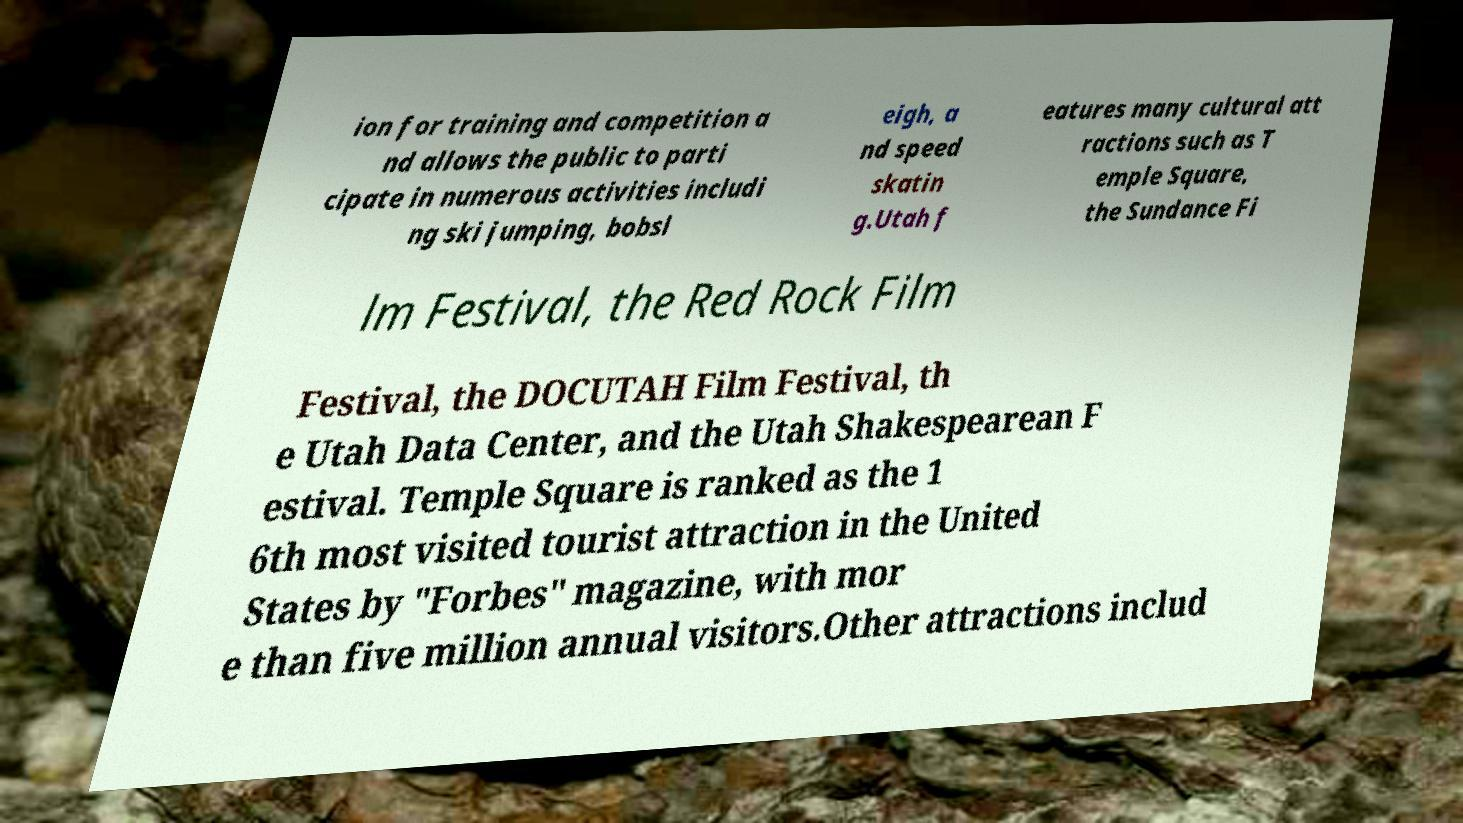Can you accurately transcribe the text from the provided image for me? ion for training and competition a nd allows the public to parti cipate in numerous activities includi ng ski jumping, bobsl eigh, a nd speed skatin g.Utah f eatures many cultural att ractions such as T emple Square, the Sundance Fi lm Festival, the Red Rock Film Festival, the DOCUTAH Film Festival, th e Utah Data Center, and the Utah Shakespearean F estival. Temple Square is ranked as the 1 6th most visited tourist attraction in the United States by "Forbes" magazine, with mor e than five million annual visitors.Other attractions includ 